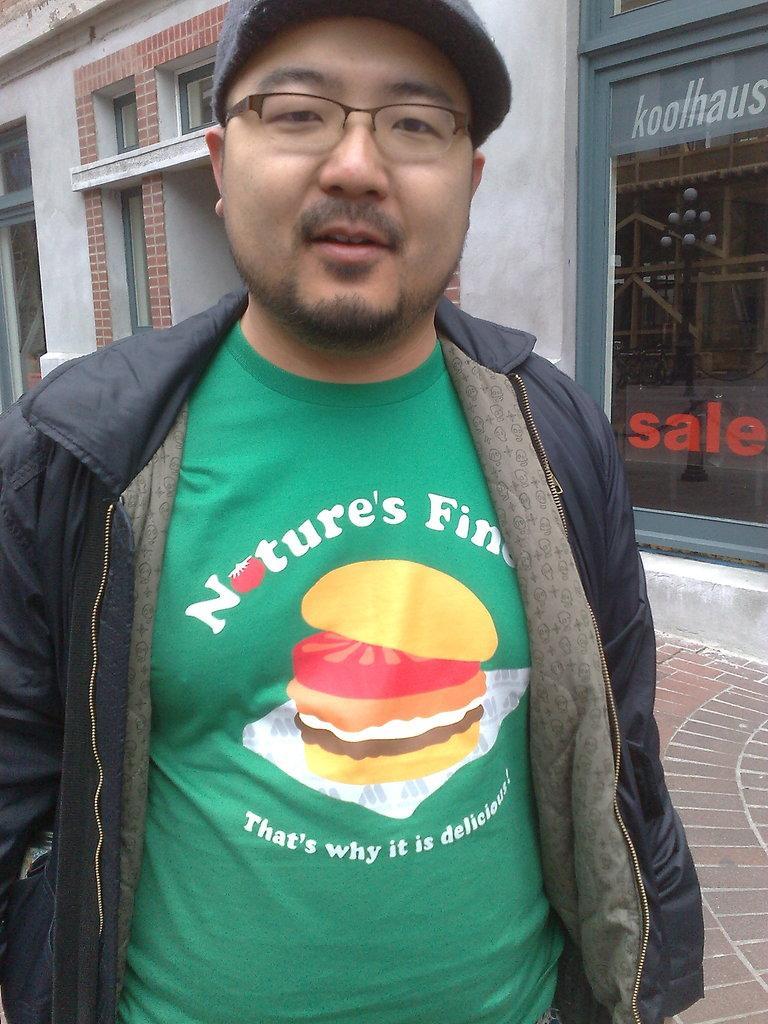Please provide a concise description of this image. In the center of the image we can see a man is wearing hoodie, spectacles, hat. In the background of the image we can see wall, doors, windows, building are there. At the bottom of the image floor is present. 